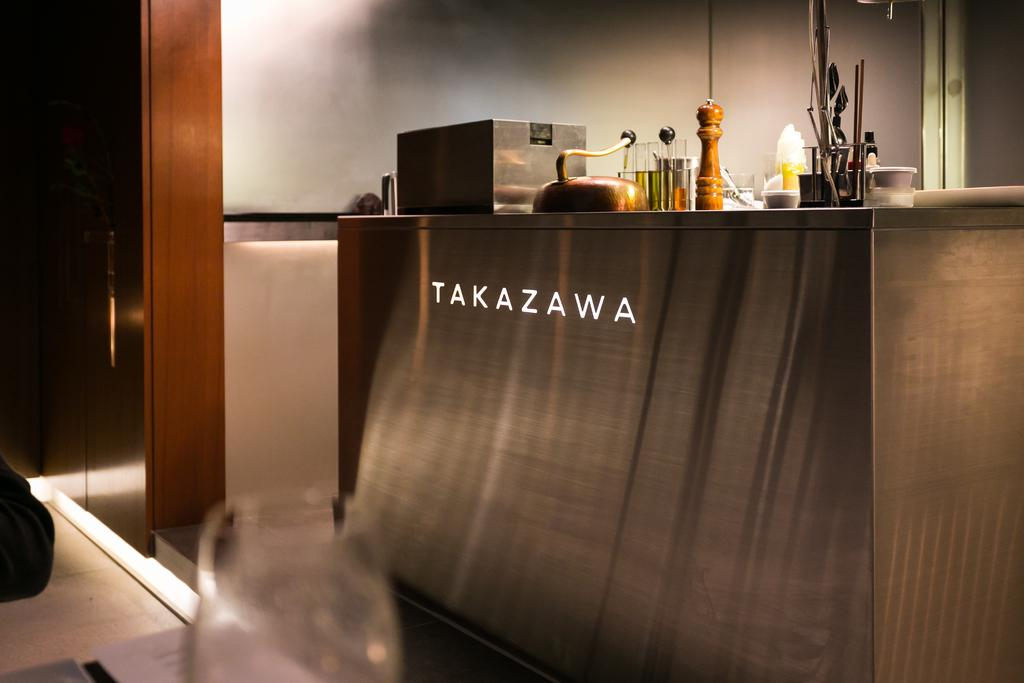What is on the table in the image? There are objects on the table in the image. Can you describe one of the objects on the table? There is a glass on the table in the image. What else can be seen in the image besides the objects on the table? There is a paper in the image. What can be seen in the background of the image? There is a wall in the background of the image. What is visible beneath the table in the image? There is a floor visible in the image. What type of wrench is being used to work on the wall in the image? There is no wrench or any work being done on the wall in the image. 